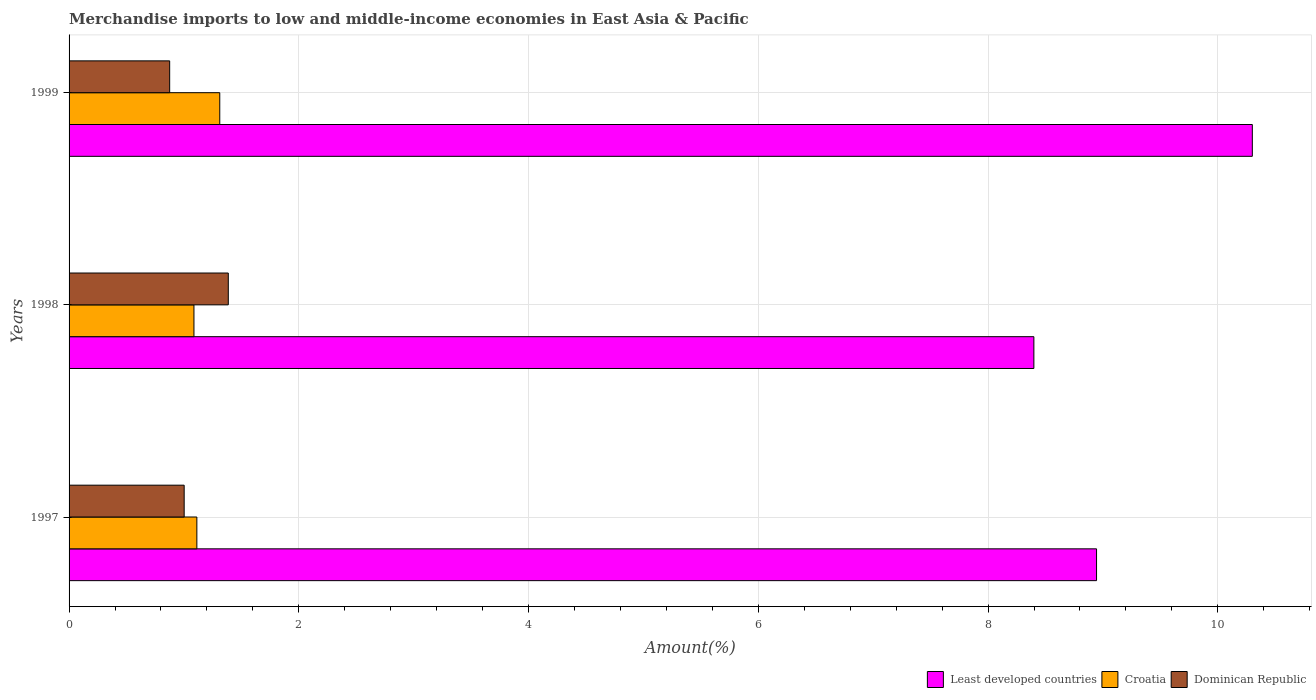How many different coloured bars are there?
Offer a very short reply. 3. Are the number of bars per tick equal to the number of legend labels?
Provide a short and direct response. Yes. How many bars are there on the 3rd tick from the top?
Your answer should be compact. 3. What is the percentage of amount earned from merchandise imports in Croatia in 1997?
Ensure brevity in your answer.  1.11. Across all years, what is the maximum percentage of amount earned from merchandise imports in Least developed countries?
Your answer should be compact. 10.3. Across all years, what is the minimum percentage of amount earned from merchandise imports in Least developed countries?
Keep it short and to the point. 8.4. In which year was the percentage of amount earned from merchandise imports in Dominican Republic maximum?
Keep it short and to the point. 1998. What is the total percentage of amount earned from merchandise imports in Least developed countries in the graph?
Keep it short and to the point. 27.64. What is the difference between the percentage of amount earned from merchandise imports in Croatia in 1998 and that in 1999?
Offer a terse response. -0.22. What is the difference between the percentage of amount earned from merchandise imports in Croatia in 1997 and the percentage of amount earned from merchandise imports in Least developed countries in 1998?
Provide a short and direct response. -7.29. What is the average percentage of amount earned from merchandise imports in Croatia per year?
Offer a very short reply. 1.17. In the year 1998, what is the difference between the percentage of amount earned from merchandise imports in Croatia and percentage of amount earned from merchandise imports in Least developed countries?
Keep it short and to the point. -7.31. In how many years, is the percentage of amount earned from merchandise imports in Dominican Republic greater than 3.6 %?
Give a very brief answer. 0. What is the ratio of the percentage of amount earned from merchandise imports in Dominican Republic in 1998 to that in 1999?
Your answer should be compact. 1.58. Is the difference between the percentage of amount earned from merchandise imports in Croatia in 1997 and 1998 greater than the difference between the percentage of amount earned from merchandise imports in Least developed countries in 1997 and 1998?
Your response must be concise. No. What is the difference between the highest and the second highest percentage of amount earned from merchandise imports in Croatia?
Make the answer very short. 0.2. What is the difference between the highest and the lowest percentage of amount earned from merchandise imports in Least developed countries?
Your response must be concise. 1.9. Is the sum of the percentage of amount earned from merchandise imports in Least developed countries in 1997 and 1998 greater than the maximum percentage of amount earned from merchandise imports in Dominican Republic across all years?
Your answer should be very brief. Yes. What does the 1st bar from the top in 1997 represents?
Your answer should be compact. Dominican Republic. What does the 2nd bar from the bottom in 1997 represents?
Offer a very short reply. Croatia. Is it the case that in every year, the sum of the percentage of amount earned from merchandise imports in Least developed countries and percentage of amount earned from merchandise imports in Dominican Republic is greater than the percentage of amount earned from merchandise imports in Croatia?
Ensure brevity in your answer.  Yes. Are all the bars in the graph horizontal?
Your response must be concise. Yes. How many years are there in the graph?
Keep it short and to the point. 3. Are the values on the major ticks of X-axis written in scientific E-notation?
Give a very brief answer. No. Does the graph contain grids?
Ensure brevity in your answer.  Yes. How many legend labels are there?
Give a very brief answer. 3. How are the legend labels stacked?
Your response must be concise. Horizontal. What is the title of the graph?
Offer a very short reply. Merchandise imports to low and middle-income economies in East Asia & Pacific. Does "Indonesia" appear as one of the legend labels in the graph?
Offer a very short reply. No. What is the label or title of the X-axis?
Offer a terse response. Amount(%). What is the Amount(%) in Least developed countries in 1997?
Provide a succinct answer. 8.94. What is the Amount(%) of Croatia in 1997?
Offer a very short reply. 1.11. What is the Amount(%) of Dominican Republic in 1997?
Your response must be concise. 1. What is the Amount(%) in Least developed countries in 1998?
Provide a short and direct response. 8.4. What is the Amount(%) of Croatia in 1998?
Make the answer very short. 1.09. What is the Amount(%) in Dominican Republic in 1998?
Ensure brevity in your answer.  1.39. What is the Amount(%) of Least developed countries in 1999?
Give a very brief answer. 10.3. What is the Amount(%) of Croatia in 1999?
Your answer should be compact. 1.31. What is the Amount(%) in Dominican Republic in 1999?
Ensure brevity in your answer.  0.88. Across all years, what is the maximum Amount(%) in Least developed countries?
Ensure brevity in your answer.  10.3. Across all years, what is the maximum Amount(%) of Croatia?
Give a very brief answer. 1.31. Across all years, what is the maximum Amount(%) of Dominican Republic?
Offer a very short reply. 1.39. Across all years, what is the minimum Amount(%) of Least developed countries?
Offer a very short reply. 8.4. Across all years, what is the minimum Amount(%) of Croatia?
Provide a succinct answer. 1.09. Across all years, what is the minimum Amount(%) of Dominican Republic?
Offer a very short reply. 0.88. What is the total Amount(%) in Least developed countries in the graph?
Your answer should be very brief. 27.64. What is the total Amount(%) in Croatia in the graph?
Provide a succinct answer. 3.51. What is the total Amount(%) in Dominican Republic in the graph?
Your response must be concise. 3.26. What is the difference between the Amount(%) in Least developed countries in 1997 and that in 1998?
Make the answer very short. 0.55. What is the difference between the Amount(%) of Croatia in 1997 and that in 1998?
Keep it short and to the point. 0.03. What is the difference between the Amount(%) in Dominican Republic in 1997 and that in 1998?
Provide a succinct answer. -0.38. What is the difference between the Amount(%) of Least developed countries in 1997 and that in 1999?
Your response must be concise. -1.36. What is the difference between the Amount(%) in Croatia in 1997 and that in 1999?
Ensure brevity in your answer.  -0.2. What is the difference between the Amount(%) of Dominican Republic in 1997 and that in 1999?
Ensure brevity in your answer.  0.13. What is the difference between the Amount(%) of Least developed countries in 1998 and that in 1999?
Keep it short and to the point. -1.9. What is the difference between the Amount(%) of Croatia in 1998 and that in 1999?
Your response must be concise. -0.22. What is the difference between the Amount(%) of Dominican Republic in 1998 and that in 1999?
Offer a very short reply. 0.51. What is the difference between the Amount(%) in Least developed countries in 1997 and the Amount(%) in Croatia in 1998?
Your answer should be compact. 7.86. What is the difference between the Amount(%) of Least developed countries in 1997 and the Amount(%) of Dominican Republic in 1998?
Your answer should be very brief. 7.56. What is the difference between the Amount(%) of Croatia in 1997 and the Amount(%) of Dominican Republic in 1998?
Ensure brevity in your answer.  -0.27. What is the difference between the Amount(%) of Least developed countries in 1997 and the Amount(%) of Croatia in 1999?
Your answer should be compact. 7.63. What is the difference between the Amount(%) of Least developed countries in 1997 and the Amount(%) of Dominican Republic in 1999?
Offer a terse response. 8.07. What is the difference between the Amount(%) of Croatia in 1997 and the Amount(%) of Dominican Republic in 1999?
Give a very brief answer. 0.24. What is the difference between the Amount(%) in Least developed countries in 1998 and the Amount(%) in Croatia in 1999?
Provide a succinct answer. 7.09. What is the difference between the Amount(%) of Least developed countries in 1998 and the Amount(%) of Dominican Republic in 1999?
Your response must be concise. 7.52. What is the difference between the Amount(%) in Croatia in 1998 and the Amount(%) in Dominican Republic in 1999?
Your response must be concise. 0.21. What is the average Amount(%) in Least developed countries per year?
Provide a succinct answer. 9.21. What is the average Amount(%) of Croatia per year?
Ensure brevity in your answer.  1.17. What is the average Amount(%) in Dominican Republic per year?
Your response must be concise. 1.09. In the year 1997, what is the difference between the Amount(%) of Least developed countries and Amount(%) of Croatia?
Ensure brevity in your answer.  7.83. In the year 1997, what is the difference between the Amount(%) in Least developed countries and Amount(%) in Dominican Republic?
Offer a very short reply. 7.94. In the year 1997, what is the difference between the Amount(%) of Croatia and Amount(%) of Dominican Republic?
Keep it short and to the point. 0.11. In the year 1998, what is the difference between the Amount(%) of Least developed countries and Amount(%) of Croatia?
Offer a very short reply. 7.31. In the year 1998, what is the difference between the Amount(%) in Least developed countries and Amount(%) in Dominican Republic?
Your answer should be very brief. 7.01. In the year 1998, what is the difference between the Amount(%) of Croatia and Amount(%) of Dominican Republic?
Provide a succinct answer. -0.3. In the year 1999, what is the difference between the Amount(%) of Least developed countries and Amount(%) of Croatia?
Provide a succinct answer. 8.99. In the year 1999, what is the difference between the Amount(%) in Least developed countries and Amount(%) in Dominican Republic?
Your response must be concise. 9.42. In the year 1999, what is the difference between the Amount(%) in Croatia and Amount(%) in Dominican Republic?
Provide a short and direct response. 0.44. What is the ratio of the Amount(%) of Least developed countries in 1997 to that in 1998?
Your answer should be compact. 1.06. What is the ratio of the Amount(%) in Croatia in 1997 to that in 1998?
Make the answer very short. 1.02. What is the ratio of the Amount(%) of Dominican Republic in 1997 to that in 1998?
Provide a short and direct response. 0.72. What is the ratio of the Amount(%) in Least developed countries in 1997 to that in 1999?
Provide a short and direct response. 0.87. What is the ratio of the Amount(%) in Croatia in 1997 to that in 1999?
Make the answer very short. 0.85. What is the ratio of the Amount(%) in Dominican Republic in 1997 to that in 1999?
Offer a terse response. 1.14. What is the ratio of the Amount(%) of Least developed countries in 1998 to that in 1999?
Ensure brevity in your answer.  0.82. What is the ratio of the Amount(%) in Croatia in 1998 to that in 1999?
Your response must be concise. 0.83. What is the ratio of the Amount(%) of Dominican Republic in 1998 to that in 1999?
Keep it short and to the point. 1.58. What is the difference between the highest and the second highest Amount(%) in Least developed countries?
Keep it short and to the point. 1.36. What is the difference between the highest and the second highest Amount(%) of Croatia?
Keep it short and to the point. 0.2. What is the difference between the highest and the second highest Amount(%) of Dominican Republic?
Provide a short and direct response. 0.38. What is the difference between the highest and the lowest Amount(%) in Least developed countries?
Make the answer very short. 1.9. What is the difference between the highest and the lowest Amount(%) in Croatia?
Ensure brevity in your answer.  0.22. What is the difference between the highest and the lowest Amount(%) in Dominican Republic?
Your answer should be very brief. 0.51. 